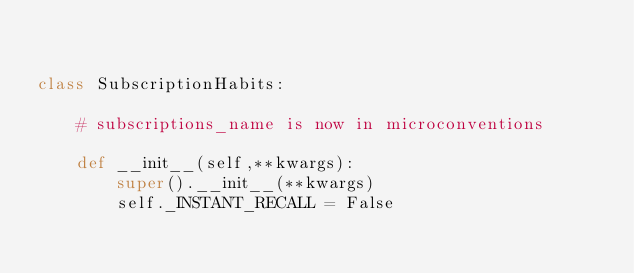<code> <loc_0><loc_0><loc_500><loc_500><_Python_>

class SubscriptionHabits:

    # subscriptions_name is now in microconventions

    def __init__(self,**kwargs):
        super().__init__(**kwargs)
        self._INSTANT_RECALL = False

</code> 